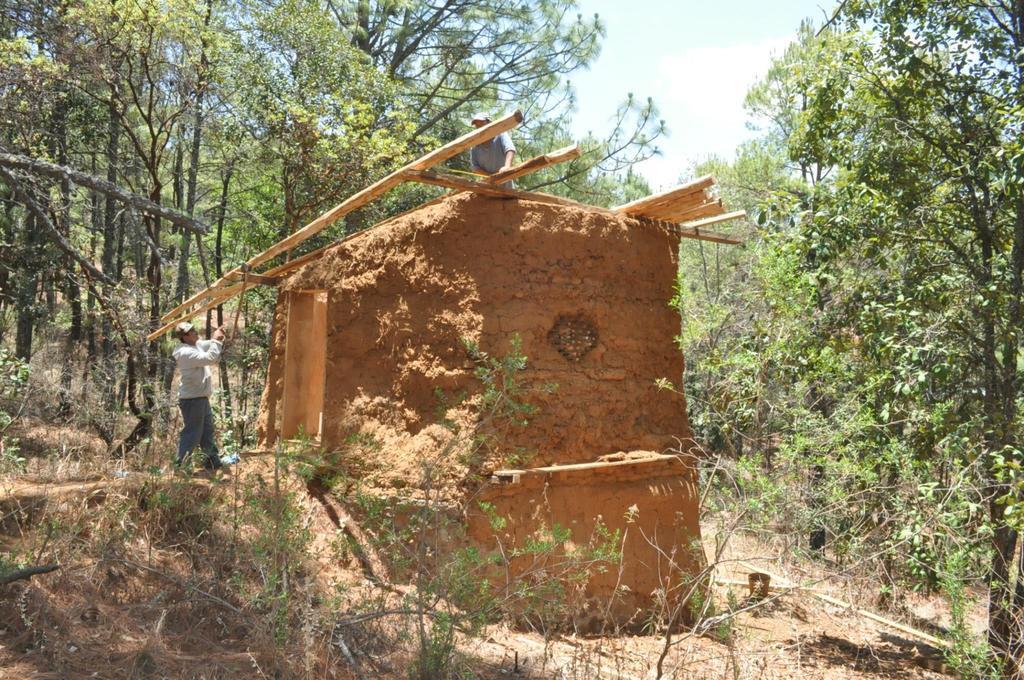Please provide a concise description of this image. In this picture we can see some plants at the bottom, on the left side there is a person standing, we can see a wall in the middle, in the background we can see some trees, there is the sky at the top of the picture, we can also see some bamboo sticks and another person in the middle. 